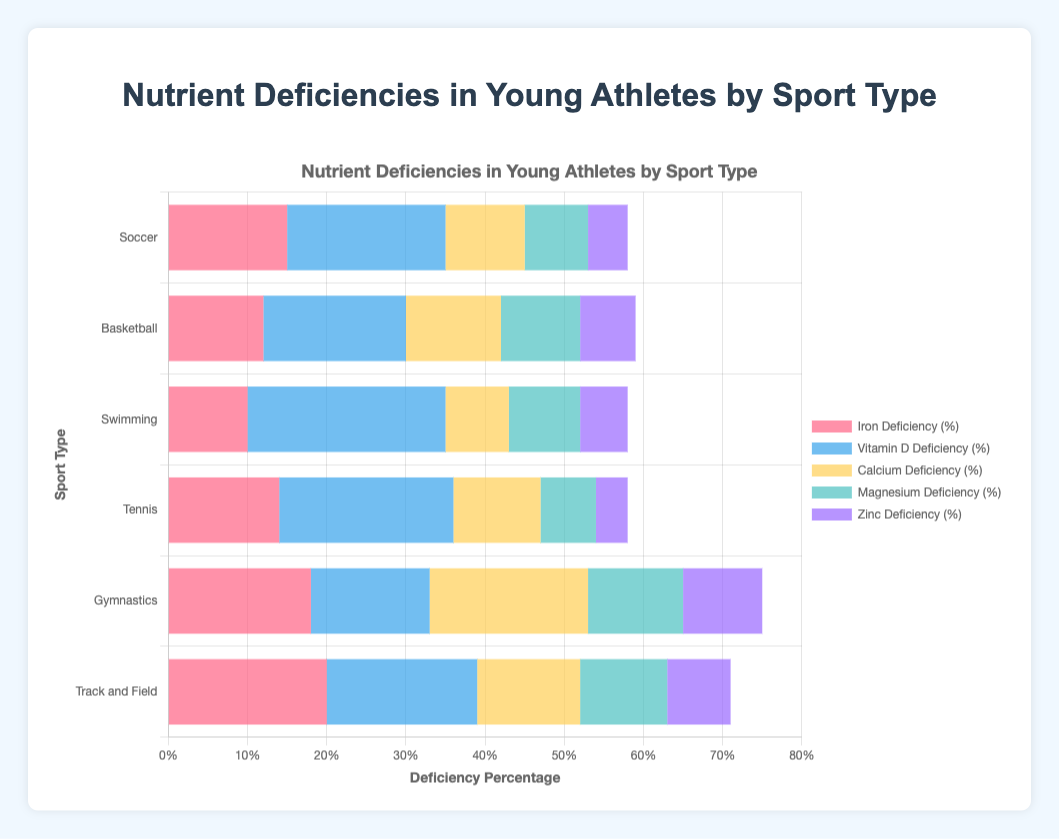What sport has the highest percentage of Iron Deficiency? From the chart, the Iron Deficiency percentage is the highest for Track and Field with 20%.
Answer: Track and Field Compare Vitamin D Deficiency between Tennis and Gymnastics. Which sport has a higher percentage? Tennis has a Vitamin D Deficiency percentage of 22%, while Gymnastics has 15%. Therefore, Tennis has a higher percentage.
Answer: Tennis Which nutrient has the smallest percentage of deficiency in Soccer players? The chart shows that Zinc Deficiency in Soccer players is 5%, which is the smallest percentage among the listed nutrients for this sport.
Answer: Zinc Deficiency For basketball players, what is the average percentage deficiency for Iron, Vitamin D, and Calcium? The deficiency percentages for Iron, Vitamin D, and Calcium in basketball players are 12%, 18%, and 12% respectively. The average is (12 + 18 + 12) / 3 = 14%.
Answer: 14% In which sport do we see the highest percentage of Calcium Deficiency? Gymnastics has the highest percentage of Calcium Deficiency at 20%.
Answer: Gymnastics Combine Iron and Magnesium Deficiency percentages for Soccer. What is the total percentage? Iron Deficiency in Soccer is 15%, and Magnesium Deficiency is 8%. The total percentage is 15% + 8% = 23%.
Answer: 23% Which nutrient shows the highest deficiency rate in Swimming? Vitamin D Deficiency in Swimming is 25%, which is the highest among all listed nutrients for this sport.
Answer: Vitamin D Deficiency How does the Zinc Deficiency percentage in Tennis compare to that in Gymnastics? Zinc Deficiency in Tennis is 4%, while in Gymnastics it is 10%. Therefore, Tennis has a lower Zinc Deficiency percentage.
Answer: Tennis What is the difference in Iron Deficiency percentages between Track and Field and Swimming? Track and Field has an Iron Deficiency percentage of 20%, and Swimming has 10%. The difference is 20% - 10% = 10%.
Answer: 10% If you add up the Calcium Deficiency percentages for all sports, what is the total? The Calcium Deficiency percentages for all sports are 10%, 12%, 8%, 11%, 20%, and 13%. The total is 10 + 12 + 8 + 11 + 20 + 13 = 74%.
Answer: 74% 